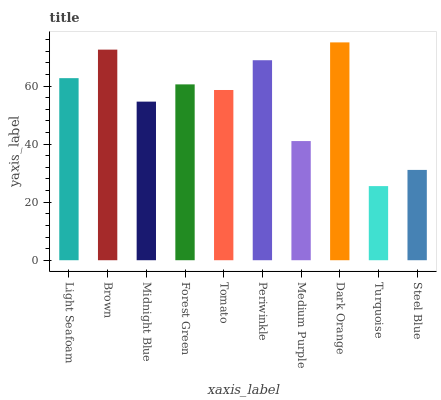Is Brown the minimum?
Answer yes or no. No. Is Brown the maximum?
Answer yes or no. No. Is Brown greater than Light Seafoam?
Answer yes or no. Yes. Is Light Seafoam less than Brown?
Answer yes or no. Yes. Is Light Seafoam greater than Brown?
Answer yes or no. No. Is Brown less than Light Seafoam?
Answer yes or no. No. Is Forest Green the high median?
Answer yes or no. Yes. Is Tomato the low median?
Answer yes or no. Yes. Is Light Seafoam the high median?
Answer yes or no. No. Is Steel Blue the low median?
Answer yes or no. No. 